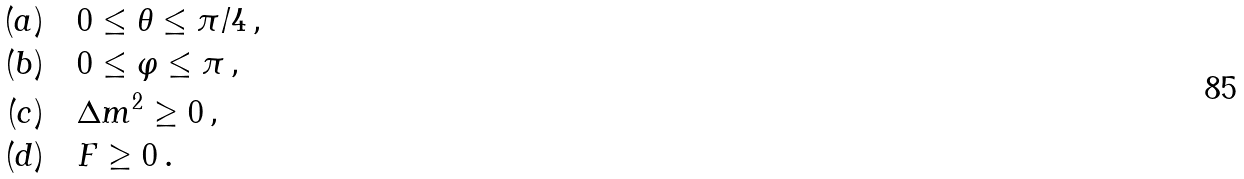<formula> <loc_0><loc_0><loc_500><loc_500>( a ) \quad & 0 \leq \theta \leq \pi / 4 \, , \\ ( b ) \quad & 0 \leq \varphi \leq \pi \, , \\ ( c ) \quad & \Delta m ^ { 2 } \geq 0 \, , \\ ( d ) \quad & F \geq 0 \, .</formula> 